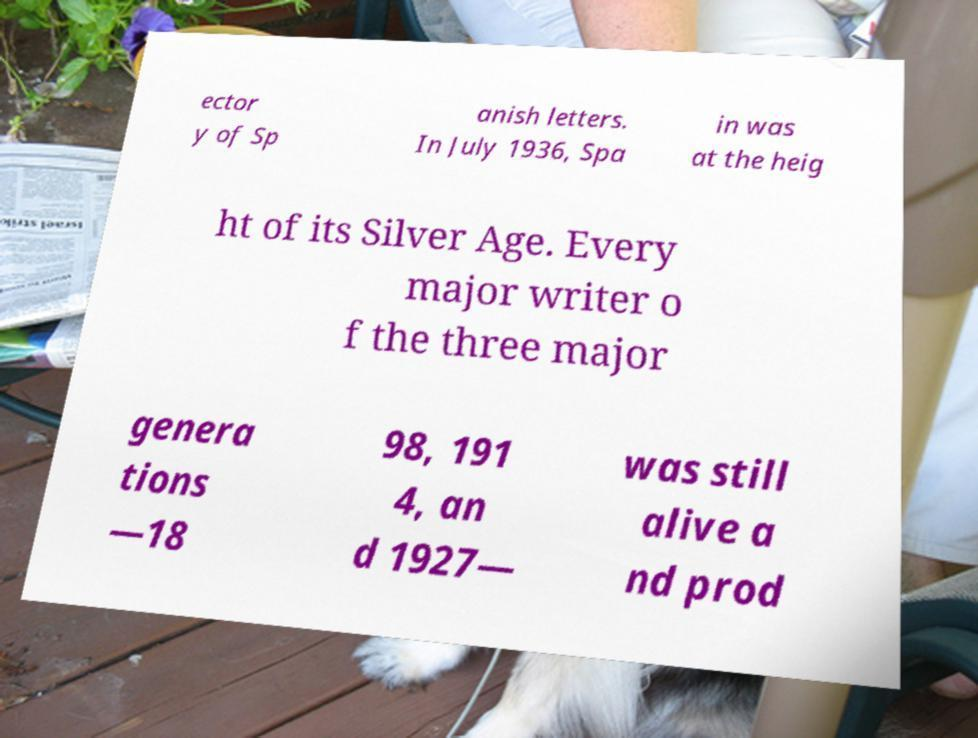For documentation purposes, I need the text within this image transcribed. Could you provide that? ector y of Sp anish letters. In July 1936, Spa in was at the heig ht of its Silver Age. Every major writer o f the three major genera tions —18 98, 191 4, an d 1927— was still alive a nd prod 